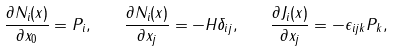<formula> <loc_0><loc_0><loc_500><loc_500>\frac { \partial { N _ { i } ( x ) } } { \partial { x _ { 0 } } } = P _ { i } , \quad \frac { \partial { N _ { i } ( x ) } } { \partial { x _ { j } } } = - H { \delta } _ { i j } , \quad \frac { \partial { J _ { i } ( x ) } } { \partial { x _ { j } } } = - { \epsilon } _ { i j k } P _ { k } ,</formula> 